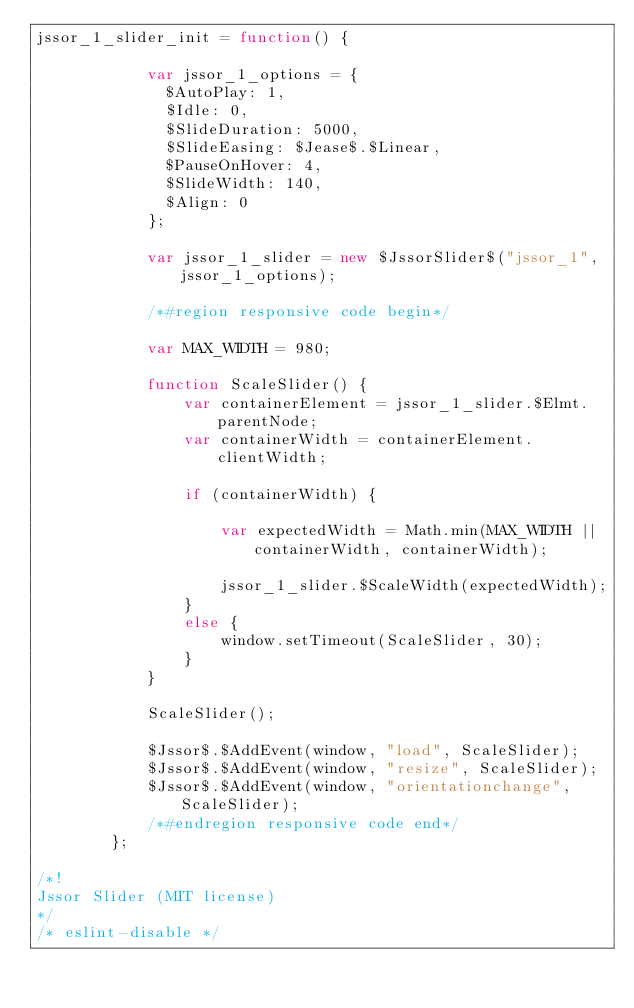Convert code to text. <code><loc_0><loc_0><loc_500><loc_500><_JavaScript_>jssor_1_slider_init = function() {

            var jssor_1_options = {
              $AutoPlay: 1,
              $Idle: 0,
              $SlideDuration: 5000,
              $SlideEasing: $Jease$.$Linear,
              $PauseOnHover: 4,
              $SlideWidth: 140,
              $Align: 0
            };

            var jssor_1_slider = new $JssorSlider$("jssor_1", jssor_1_options);

            /*#region responsive code begin*/

            var MAX_WIDTH = 980;

            function ScaleSlider() {
                var containerElement = jssor_1_slider.$Elmt.parentNode;
                var containerWidth = containerElement.clientWidth;

                if (containerWidth) {

                    var expectedWidth = Math.min(MAX_WIDTH || containerWidth, containerWidth);

                    jssor_1_slider.$ScaleWidth(expectedWidth);
                }
                else {
                    window.setTimeout(ScaleSlider, 30);
                }
            }

            ScaleSlider();

            $Jssor$.$AddEvent(window, "load", ScaleSlider);
            $Jssor$.$AddEvent(window, "resize", ScaleSlider);
            $Jssor$.$AddEvent(window, "orientationchange", ScaleSlider);
            /*#endregion responsive code end*/
        };

/*!
Jssor Slider (MIT license)
*/
/* eslint-disable */</code> 